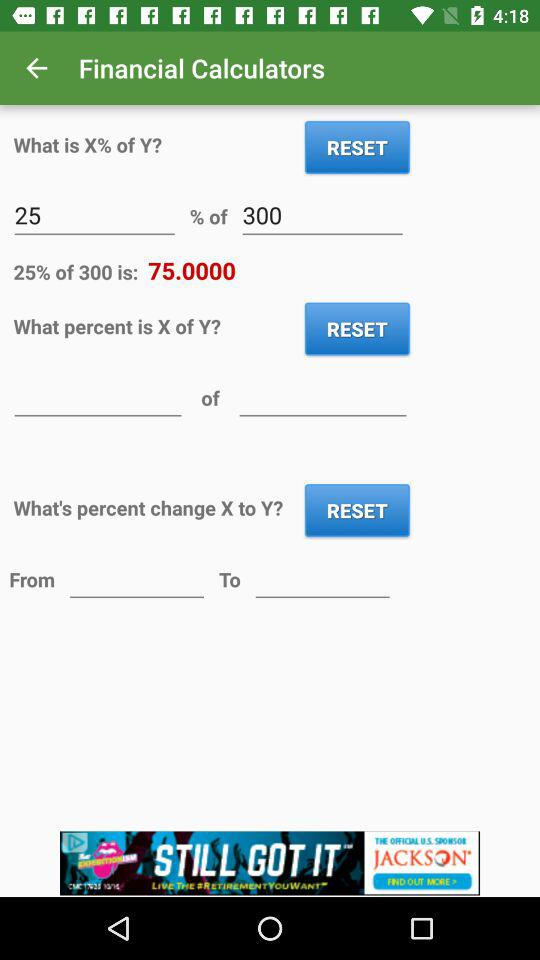What is the name of the application? The name of the application is "Financial Calculators". 